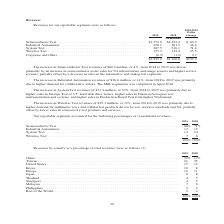According to Teradyne's financial document, What was the change in Industrial Automation revenues? According to the financial document, $36.6 million. The relevant text states: "The increase in Industrial Automation revenues of $36.6 million, or 14%, from 2018 to 2019 was primarily due to higher demand for collaborative robots. The MiR acq..." Also, What was the change in System Test revenues? According to the financial document, $71.4 million. The relevant text states: "The increase in System Test revenues of $71.4 million, or 33%, from 2018 to 2019 was primarily due to higher sales in Storage Test of 3.5” hard disk driv..." Also, What were the reportable segments in the table? The document contains multiple relevant values: Semiconductor Test, Industrial Automation, System Test, Wireless Test, Corporate and Other. From the document: "4 $ 60.2 Industrial Automation . 298.1 261.5 36.6 System Test . 287.5 216.1 71.4 Wireless Test . 157.3 132.0 25.3 Corporate and Other . (0.5) (1.2) 0...." Additionally, In which year was Wireless Test larger? According to the financial document, 2019. The relevant text states: "2019 2018..." Also, can you calculate: What was the average revenue from System Test in 2018 and 2019? To answer this question, I need to perform calculations using the financial data. The calculation is: (287.5+216.1)/2, which equals 251.8 (in millions). This is based on the information: "Automation . 298.1 261.5 36.6 System Test . 287.5 216.1 71.4 Wireless Test . 157.3 132.0 25.3 Corporate and Other . (0.5) (1.2) 0.7 trial Automation . 298.1 261.5 36.6 System Test . 287.5 216.1 71.4 W..." The key data points involved are: 216.1, 287.5. Also, can you calculate: What was the average total revenue in 2018 and 2019? To answer this question, I need to perform calculations using the financial data. The calculation is: (2,295.0+2,100.8)/2, which equals 2197.9 (in millions). This is based on the information: "$2,295.0 $2,100.8 $194.2 $2,295.0 $2,100.8 $194.2..." The key data points involved are: 2,100.8, 2,295.0. 